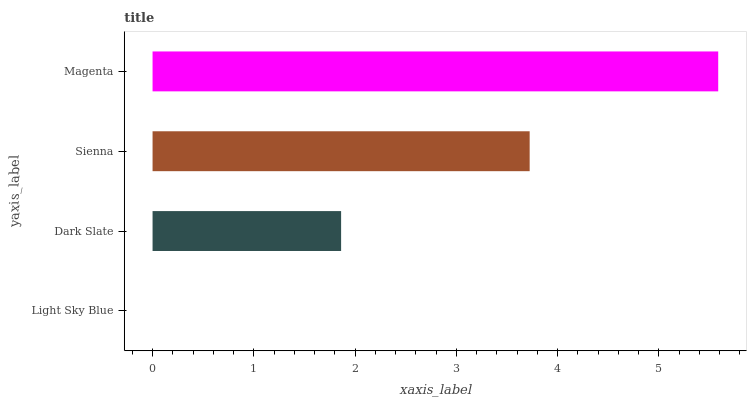Is Light Sky Blue the minimum?
Answer yes or no. Yes. Is Magenta the maximum?
Answer yes or no. Yes. Is Dark Slate the minimum?
Answer yes or no. No. Is Dark Slate the maximum?
Answer yes or no. No. Is Dark Slate greater than Light Sky Blue?
Answer yes or no. Yes. Is Light Sky Blue less than Dark Slate?
Answer yes or no. Yes. Is Light Sky Blue greater than Dark Slate?
Answer yes or no. No. Is Dark Slate less than Light Sky Blue?
Answer yes or no. No. Is Sienna the high median?
Answer yes or no. Yes. Is Dark Slate the low median?
Answer yes or no. Yes. Is Light Sky Blue the high median?
Answer yes or no. No. Is Light Sky Blue the low median?
Answer yes or no. No. 